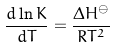<formula> <loc_0><loc_0><loc_500><loc_500>\frac { d \ln K } { d T } = \frac { { \Delta H } ^ { \ominus } } { R T ^ { 2 } }</formula> 